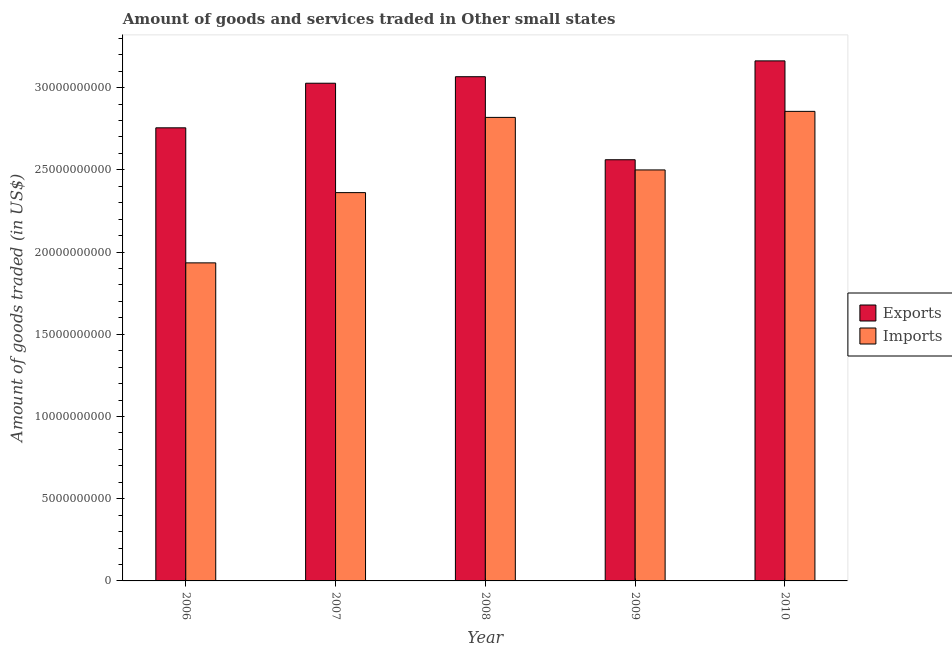How many groups of bars are there?
Ensure brevity in your answer.  5. Are the number of bars per tick equal to the number of legend labels?
Your response must be concise. Yes. How many bars are there on the 2nd tick from the right?
Offer a terse response. 2. In how many cases, is the number of bars for a given year not equal to the number of legend labels?
Your answer should be very brief. 0. What is the amount of goods imported in 2009?
Provide a succinct answer. 2.50e+1. Across all years, what is the maximum amount of goods imported?
Offer a terse response. 2.86e+1. Across all years, what is the minimum amount of goods exported?
Give a very brief answer. 2.56e+1. In which year was the amount of goods imported minimum?
Provide a short and direct response. 2006. What is the total amount of goods exported in the graph?
Ensure brevity in your answer.  1.46e+11. What is the difference between the amount of goods imported in 2009 and that in 2010?
Keep it short and to the point. -3.56e+09. What is the difference between the amount of goods exported in 2006 and the amount of goods imported in 2007?
Your answer should be compact. -2.71e+09. What is the average amount of goods imported per year?
Give a very brief answer. 2.49e+1. What is the ratio of the amount of goods exported in 2007 to that in 2010?
Give a very brief answer. 0.96. Is the amount of goods exported in 2007 less than that in 2010?
Provide a short and direct response. Yes. Is the difference between the amount of goods exported in 2009 and 2010 greater than the difference between the amount of goods imported in 2009 and 2010?
Your response must be concise. No. What is the difference between the highest and the second highest amount of goods imported?
Your answer should be very brief. 3.67e+08. What is the difference between the highest and the lowest amount of goods exported?
Provide a short and direct response. 6.01e+09. In how many years, is the amount of goods exported greater than the average amount of goods exported taken over all years?
Make the answer very short. 3. Is the sum of the amount of goods imported in 2008 and 2009 greater than the maximum amount of goods exported across all years?
Your answer should be compact. Yes. What does the 1st bar from the left in 2009 represents?
Your answer should be very brief. Exports. What does the 1st bar from the right in 2006 represents?
Your response must be concise. Imports. How many bars are there?
Your answer should be very brief. 10. How many years are there in the graph?
Make the answer very short. 5. What is the difference between two consecutive major ticks on the Y-axis?
Offer a terse response. 5.00e+09. Are the values on the major ticks of Y-axis written in scientific E-notation?
Your answer should be very brief. No. Does the graph contain any zero values?
Make the answer very short. No. Does the graph contain grids?
Make the answer very short. No. Where does the legend appear in the graph?
Make the answer very short. Center right. How many legend labels are there?
Provide a short and direct response. 2. What is the title of the graph?
Keep it short and to the point. Amount of goods and services traded in Other small states. Does "current US$" appear as one of the legend labels in the graph?
Your answer should be compact. No. What is the label or title of the X-axis?
Your answer should be very brief. Year. What is the label or title of the Y-axis?
Your answer should be compact. Amount of goods traded (in US$). What is the Amount of goods traded (in US$) of Exports in 2006?
Your answer should be compact. 2.76e+1. What is the Amount of goods traded (in US$) of Imports in 2006?
Offer a terse response. 1.93e+1. What is the Amount of goods traded (in US$) of Exports in 2007?
Give a very brief answer. 3.03e+1. What is the Amount of goods traded (in US$) in Imports in 2007?
Provide a succinct answer. 2.36e+1. What is the Amount of goods traded (in US$) of Exports in 2008?
Offer a very short reply. 3.07e+1. What is the Amount of goods traded (in US$) of Imports in 2008?
Keep it short and to the point. 2.82e+1. What is the Amount of goods traded (in US$) in Exports in 2009?
Keep it short and to the point. 2.56e+1. What is the Amount of goods traded (in US$) in Imports in 2009?
Offer a terse response. 2.50e+1. What is the Amount of goods traded (in US$) of Exports in 2010?
Provide a short and direct response. 3.16e+1. What is the Amount of goods traded (in US$) of Imports in 2010?
Keep it short and to the point. 2.86e+1. Across all years, what is the maximum Amount of goods traded (in US$) in Exports?
Ensure brevity in your answer.  3.16e+1. Across all years, what is the maximum Amount of goods traded (in US$) in Imports?
Provide a succinct answer. 2.86e+1. Across all years, what is the minimum Amount of goods traded (in US$) in Exports?
Ensure brevity in your answer.  2.56e+1. Across all years, what is the minimum Amount of goods traded (in US$) in Imports?
Your response must be concise. 1.93e+1. What is the total Amount of goods traded (in US$) of Exports in the graph?
Keep it short and to the point. 1.46e+11. What is the total Amount of goods traded (in US$) of Imports in the graph?
Make the answer very short. 1.25e+11. What is the difference between the Amount of goods traded (in US$) in Exports in 2006 and that in 2007?
Offer a terse response. -2.71e+09. What is the difference between the Amount of goods traded (in US$) in Imports in 2006 and that in 2007?
Provide a short and direct response. -4.27e+09. What is the difference between the Amount of goods traded (in US$) in Exports in 2006 and that in 2008?
Ensure brevity in your answer.  -3.11e+09. What is the difference between the Amount of goods traded (in US$) of Imports in 2006 and that in 2008?
Your answer should be very brief. -8.85e+09. What is the difference between the Amount of goods traded (in US$) in Exports in 2006 and that in 2009?
Provide a short and direct response. 1.94e+09. What is the difference between the Amount of goods traded (in US$) in Imports in 2006 and that in 2009?
Offer a very short reply. -5.65e+09. What is the difference between the Amount of goods traded (in US$) in Exports in 2006 and that in 2010?
Your answer should be very brief. -4.07e+09. What is the difference between the Amount of goods traded (in US$) of Imports in 2006 and that in 2010?
Provide a short and direct response. -9.21e+09. What is the difference between the Amount of goods traded (in US$) of Exports in 2007 and that in 2008?
Your response must be concise. -3.96e+08. What is the difference between the Amount of goods traded (in US$) in Imports in 2007 and that in 2008?
Keep it short and to the point. -4.57e+09. What is the difference between the Amount of goods traded (in US$) of Exports in 2007 and that in 2009?
Keep it short and to the point. 4.65e+09. What is the difference between the Amount of goods traded (in US$) of Imports in 2007 and that in 2009?
Give a very brief answer. -1.38e+09. What is the difference between the Amount of goods traded (in US$) in Exports in 2007 and that in 2010?
Make the answer very short. -1.36e+09. What is the difference between the Amount of goods traded (in US$) of Imports in 2007 and that in 2010?
Offer a very short reply. -4.94e+09. What is the difference between the Amount of goods traded (in US$) in Exports in 2008 and that in 2009?
Offer a terse response. 5.05e+09. What is the difference between the Amount of goods traded (in US$) in Imports in 2008 and that in 2009?
Give a very brief answer. 3.19e+09. What is the difference between the Amount of goods traded (in US$) of Exports in 2008 and that in 2010?
Provide a succinct answer. -9.63e+08. What is the difference between the Amount of goods traded (in US$) in Imports in 2008 and that in 2010?
Your response must be concise. -3.67e+08. What is the difference between the Amount of goods traded (in US$) in Exports in 2009 and that in 2010?
Keep it short and to the point. -6.01e+09. What is the difference between the Amount of goods traded (in US$) in Imports in 2009 and that in 2010?
Your answer should be very brief. -3.56e+09. What is the difference between the Amount of goods traded (in US$) of Exports in 2006 and the Amount of goods traded (in US$) of Imports in 2007?
Provide a succinct answer. 3.94e+09. What is the difference between the Amount of goods traded (in US$) of Exports in 2006 and the Amount of goods traded (in US$) of Imports in 2008?
Provide a short and direct response. -6.34e+08. What is the difference between the Amount of goods traded (in US$) of Exports in 2006 and the Amount of goods traded (in US$) of Imports in 2009?
Ensure brevity in your answer.  2.56e+09. What is the difference between the Amount of goods traded (in US$) of Exports in 2006 and the Amount of goods traded (in US$) of Imports in 2010?
Keep it short and to the point. -1.00e+09. What is the difference between the Amount of goods traded (in US$) of Exports in 2007 and the Amount of goods traded (in US$) of Imports in 2008?
Give a very brief answer. 2.08e+09. What is the difference between the Amount of goods traded (in US$) of Exports in 2007 and the Amount of goods traded (in US$) of Imports in 2009?
Your answer should be very brief. 5.27e+09. What is the difference between the Amount of goods traded (in US$) in Exports in 2007 and the Amount of goods traded (in US$) in Imports in 2010?
Keep it short and to the point. 1.71e+09. What is the difference between the Amount of goods traded (in US$) in Exports in 2008 and the Amount of goods traded (in US$) in Imports in 2009?
Make the answer very short. 5.67e+09. What is the difference between the Amount of goods traded (in US$) in Exports in 2008 and the Amount of goods traded (in US$) in Imports in 2010?
Your answer should be very brief. 2.11e+09. What is the difference between the Amount of goods traded (in US$) of Exports in 2009 and the Amount of goods traded (in US$) of Imports in 2010?
Your response must be concise. -2.94e+09. What is the average Amount of goods traded (in US$) in Exports per year?
Make the answer very short. 2.91e+1. What is the average Amount of goods traded (in US$) in Imports per year?
Keep it short and to the point. 2.49e+1. In the year 2006, what is the difference between the Amount of goods traded (in US$) in Exports and Amount of goods traded (in US$) in Imports?
Ensure brevity in your answer.  8.21e+09. In the year 2007, what is the difference between the Amount of goods traded (in US$) of Exports and Amount of goods traded (in US$) of Imports?
Provide a succinct answer. 6.65e+09. In the year 2008, what is the difference between the Amount of goods traded (in US$) of Exports and Amount of goods traded (in US$) of Imports?
Your response must be concise. 2.47e+09. In the year 2009, what is the difference between the Amount of goods traded (in US$) of Exports and Amount of goods traded (in US$) of Imports?
Make the answer very short. 6.19e+08. In the year 2010, what is the difference between the Amount of goods traded (in US$) of Exports and Amount of goods traded (in US$) of Imports?
Your answer should be very brief. 3.07e+09. What is the ratio of the Amount of goods traded (in US$) in Exports in 2006 to that in 2007?
Your answer should be compact. 0.91. What is the ratio of the Amount of goods traded (in US$) of Imports in 2006 to that in 2007?
Ensure brevity in your answer.  0.82. What is the ratio of the Amount of goods traded (in US$) of Exports in 2006 to that in 2008?
Offer a very short reply. 0.9. What is the ratio of the Amount of goods traded (in US$) in Imports in 2006 to that in 2008?
Give a very brief answer. 0.69. What is the ratio of the Amount of goods traded (in US$) of Exports in 2006 to that in 2009?
Offer a very short reply. 1.08. What is the ratio of the Amount of goods traded (in US$) in Imports in 2006 to that in 2009?
Make the answer very short. 0.77. What is the ratio of the Amount of goods traded (in US$) of Exports in 2006 to that in 2010?
Your answer should be compact. 0.87. What is the ratio of the Amount of goods traded (in US$) of Imports in 2006 to that in 2010?
Offer a terse response. 0.68. What is the ratio of the Amount of goods traded (in US$) of Exports in 2007 to that in 2008?
Your answer should be very brief. 0.99. What is the ratio of the Amount of goods traded (in US$) in Imports in 2007 to that in 2008?
Your answer should be compact. 0.84. What is the ratio of the Amount of goods traded (in US$) of Exports in 2007 to that in 2009?
Offer a terse response. 1.18. What is the ratio of the Amount of goods traded (in US$) in Imports in 2007 to that in 2009?
Keep it short and to the point. 0.94. What is the ratio of the Amount of goods traded (in US$) of Imports in 2007 to that in 2010?
Your answer should be very brief. 0.83. What is the ratio of the Amount of goods traded (in US$) of Exports in 2008 to that in 2009?
Provide a short and direct response. 1.2. What is the ratio of the Amount of goods traded (in US$) of Imports in 2008 to that in 2009?
Your answer should be compact. 1.13. What is the ratio of the Amount of goods traded (in US$) in Exports in 2008 to that in 2010?
Provide a succinct answer. 0.97. What is the ratio of the Amount of goods traded (in US$) in Imports in 2008 to that in 2010?
Provide a succinct answer. 0.99. What is the ratio of the Amount of goods traded (in US$) of Exports in 2009 to that in 2010?
Provide a short and direct response. 0.81. What is the ratio of the Amount of goods traded (in US$) of Imports in 2009 to that in 2010?
Your answer should be very brief. 0.88. What is the difference between the highest and the second highest Amount of goods traded (in US$) of Exports?
Make the answer very short. 9.63e+08. What is the difference between the highest and the second highest Amount of goods traded (in US$) of Imports?
Your answer should be very brief. 3.67e+08. What is the difference between the highest and the lowest Amount of goods traded (in US$) in Exports?
Your response must be concise. 6.01e+09. What is the difference between the highest and the lowest Amount of goods traded (in US$) in Imports?
Your answer should be compact. 9.21e+09. 